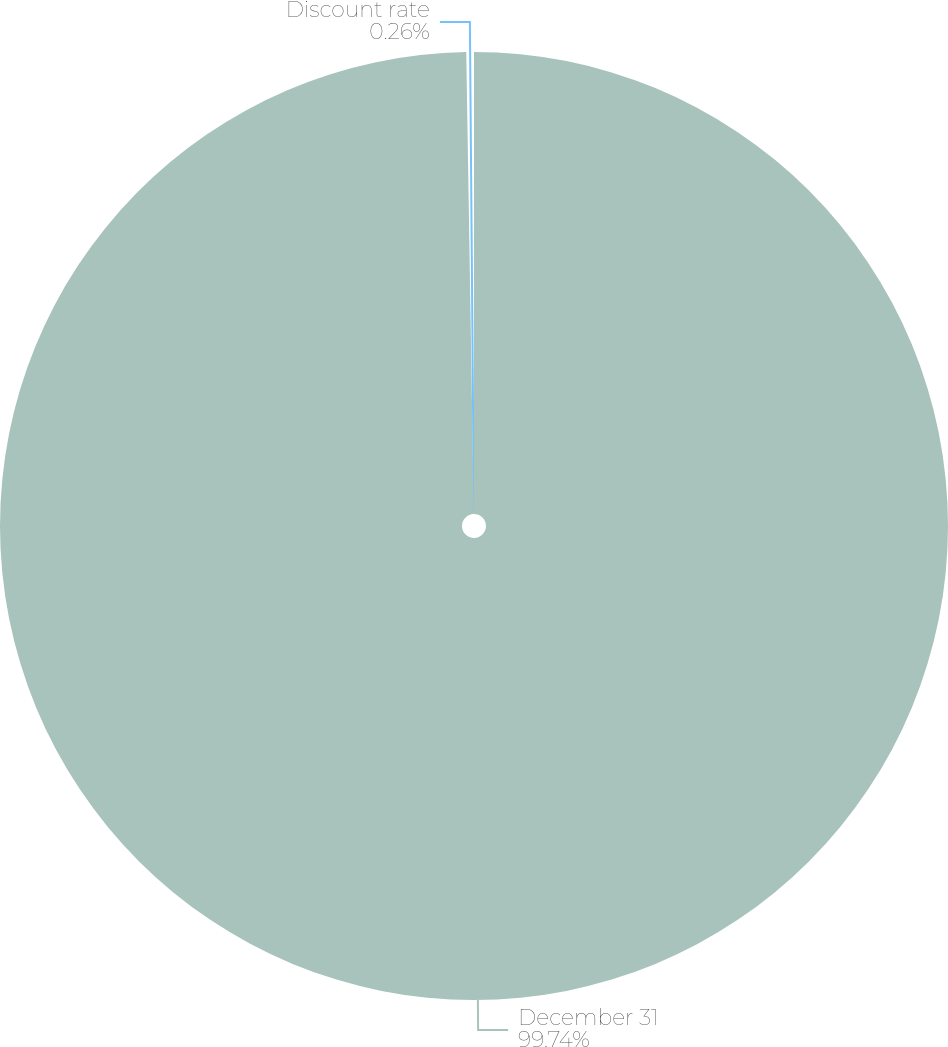<chart> <loc_0><loc_0><loc_500><loc_500><pie_chart><fcel>December 31<fcel>Discount rate<nl><fcel>99.74%<fcel>0.26%<nl></chart> 